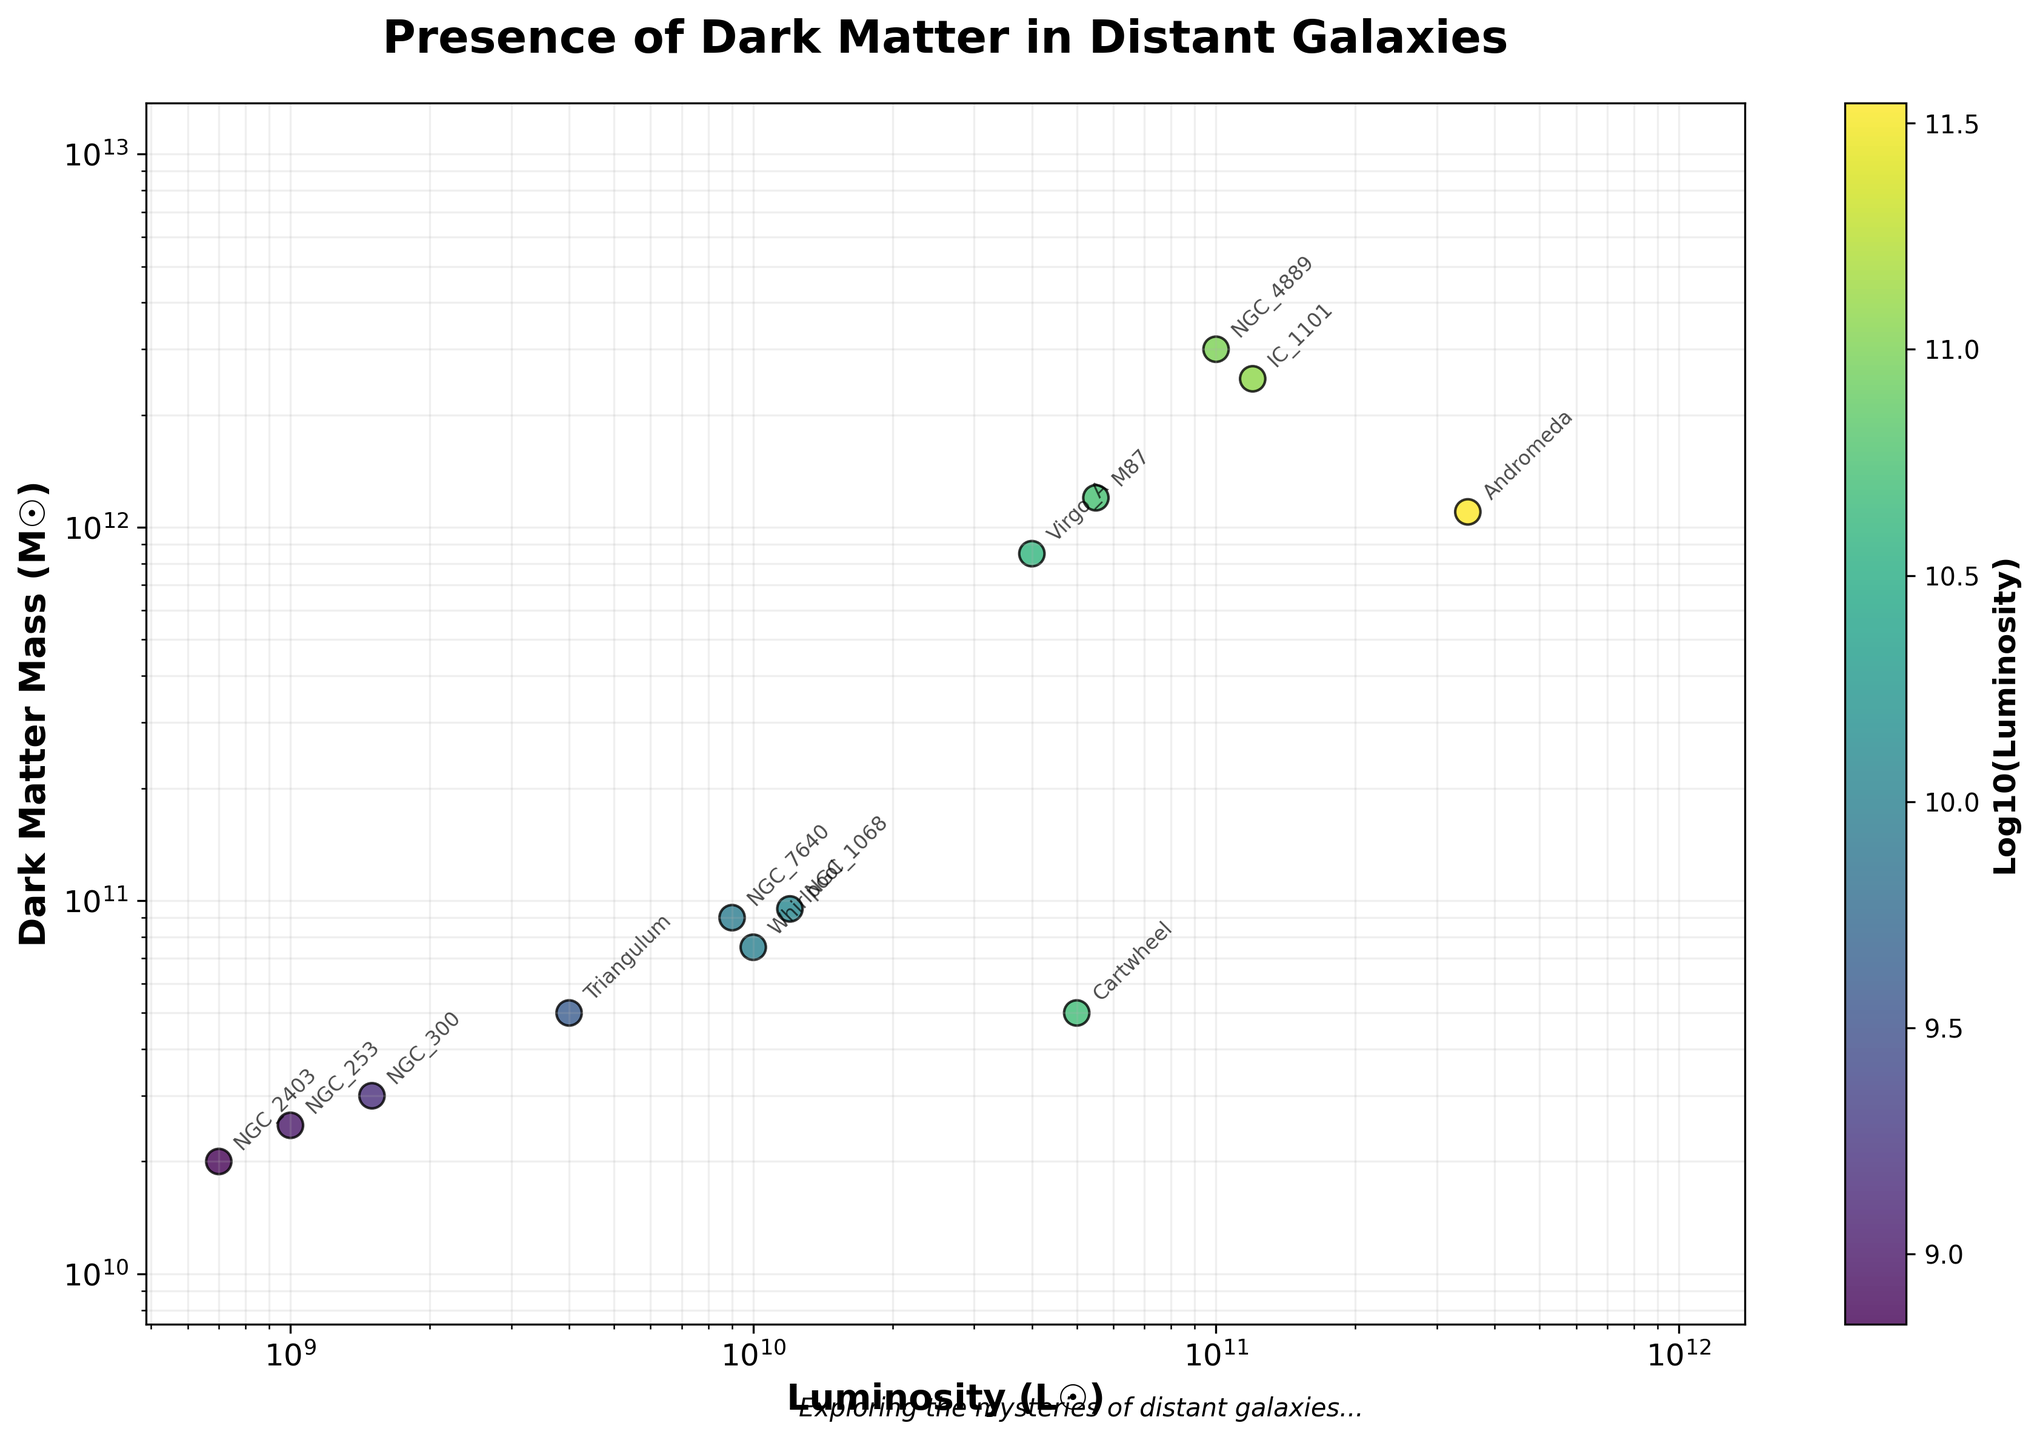What is the title of the plot? The title is located at the top center of the plot and provides a brief description of what the plot represents. Here, it reads "Presence of Dark Matter in Distant Galaxies."
Answer: Presence of Dark Matter in Distant Galaxies Which galaxy has the highest luminosity, and what is its dark matter mass? The galaxy with the highest luminosity is found by identifying the highest point on the x-axis. This corresponds to Andromeda with a luminosity of \(3.5 \times 10^{11}\) L☉ and a dark matter mass of \(1.1 \times 10^{12}\) M☉.
Answer: Andromeda, \(1.1 \times 10^{12}\) M☉ How many galaxies have a luminosity greater than \(10^{10}\) L☉? By examining the x-axis where it is marked \(10^{10}\) and counting the points to the right of this mark, we see there are 7 galaxies: NGC 4889, IC 1101, M87, Andromeda, Cartwheel, NGC 1068, and Virgo A.
Answer: 7 Which galaxy has the lowest dark matter mass? To find the galaxy with the lowest dark matter mass, look for the lowest point on the y-axis. Triangulum has the lowest dark matter mass at \(5 \times 10^{10}\) M☉.
Answer: Triangulum What does the color of the points represent? The color of the points corresponds to the logarithm (base 10) of their luminosity. This is indicated by the color bar labeled 'Log10(Luminosity)'.
Answer: Log10(Luminosity) Which galaxy has the closest value of luminosity to its dark matter mass? The galaxy where the luminosity value is closest to its dark matter mass is determined by finding points near the diagonal line where x = y. The Cartwheel galaxy has both luminosity and dark matter mass around \(5 \times 10^{10}\).
Answer: Cartwheel What trend can be observed between luminosity and dark matter mass? By observing the scatter plot, we notice that as luminosity increases, dark matter mass generally increases as well, indicating a positive correlation between the two variables.
Answer: Positive correlation Comparing IC 1101 and NGC 4889, which has a higher dark matter mass? By looking at both points on the plot, IC 1101's dark matter mass is about \(2.5 \times 10^{12}\) M☉, while NGC 4889's is about \(3 \times 10^{12}\) M☉, so NGC 4889 has a higher dark matter mass.
Answer: NGC 4889 What is the ratio of dark matter mass to luminosity for NGC 7640? The dark matter mass for NGC 7640 is \(9 \times 10^{10}\) M☉, and its luminosity is \(9 \times 10^9\) L☉. The ratio is found by dividing dark matter mass by luminosity: \(9 \times 10^{10}\) / \(9 \times 10^9\) = 10.
Answer: 10 Which galaxies are annotated with their names in the plot? By carefully observing the annotations, we see the following galaxies are labeled: NGC 4889, IC 1101, NGC 7640, M87, Andromeda, Triangulum, NGC 300, NGC 2403, Whirlpool, NGC 253, Cartwheel, NGC 1068, Virgo A.
Answer: NGC 4889, IC 1101, NGC 7640, M87, Andromeda, Triangulum, NGC 300, NGC 2403, Whirlpool, NGC 253, Cartwheel, NGC 1068, Virgo A 